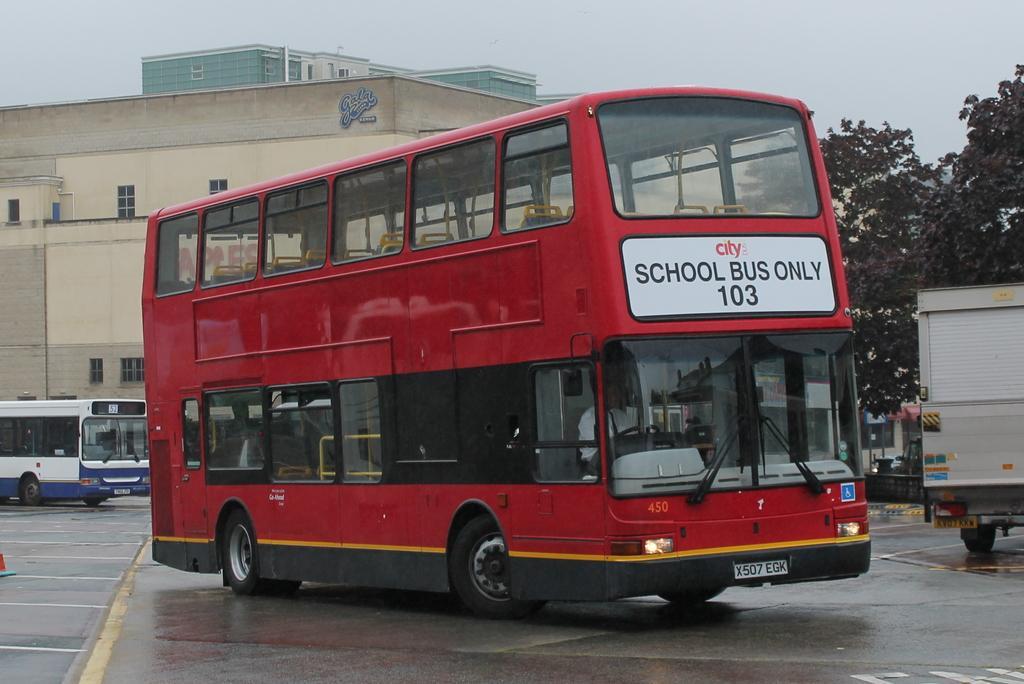How would you summarize this image in a sentence or two? In this picture we can see a double decker bus and some vehicles on the road. Behind the vehicles, there are buildings and the sky. On the right side of the image, there are trees and some objects. 